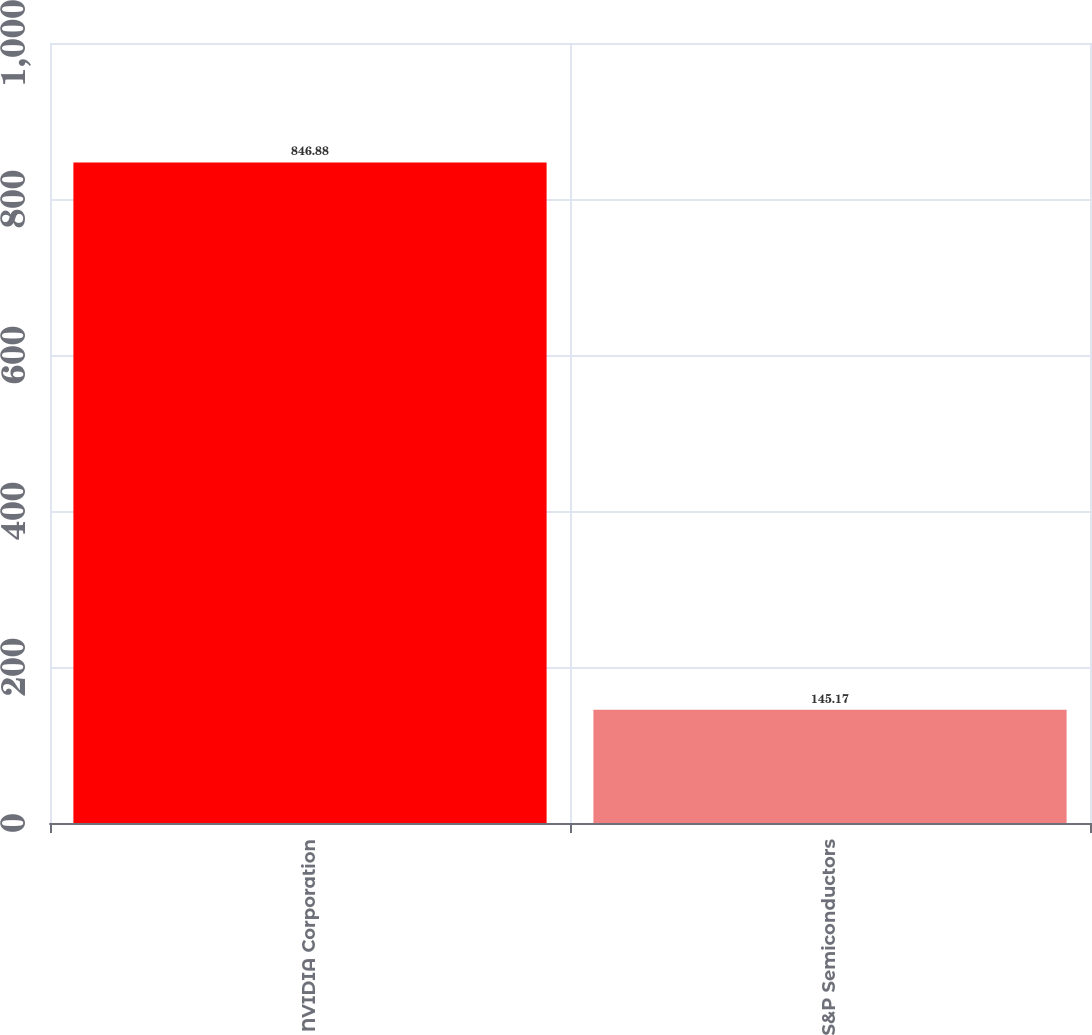Convert chart to OTSL. <chart><loc_0><loc_0><loc_500><loc_500><bar_chart><fcel>NVIDIA Corporation<fcel>S&P Semiconductors<nl><fcel>846.88<fcel>145.17<nl></chart> 